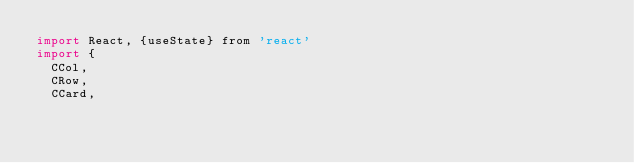<code> <loc_0><loc_0><loc_500><loc_500><_JavaScript_>import React, {useState} from 'react'
import {
  CCol,
  CRow,
  CCard,</code> 